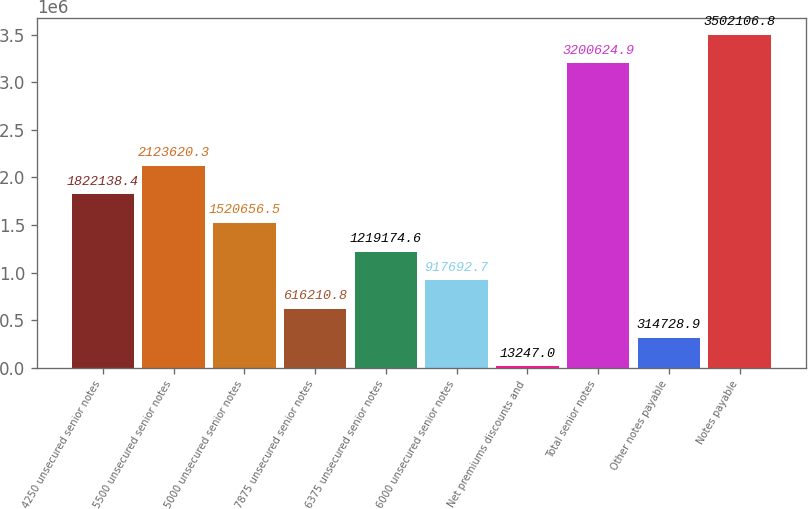Convert chart to OTSL. <chart><loc_0><loc_0><loc_500><loc_500><bar_chart><fcel>4250 unsecured senior notes<fcel>5500 unsecured senior notes<fcel>5000 unsecured senior notes<fcel>7875 unsecured senior notes<fcel>6375 unsecured senior notes<fcel>6000 unsecured senior notes<fcel>Net premiums discounts and<fcel>Total senior notes<fcel>Other notes payable<fcel>Notes payable<nl><fcel>1.82214e+06<fcel>2.12362e+06<fcel>1.52066e+06<fcel>616211<fcel>1.21917e+06<fcel>917693<fcel>13247<fcel>3.20062e+06<fcel>314729<fcel>3.50211e+06<nl></chart> 